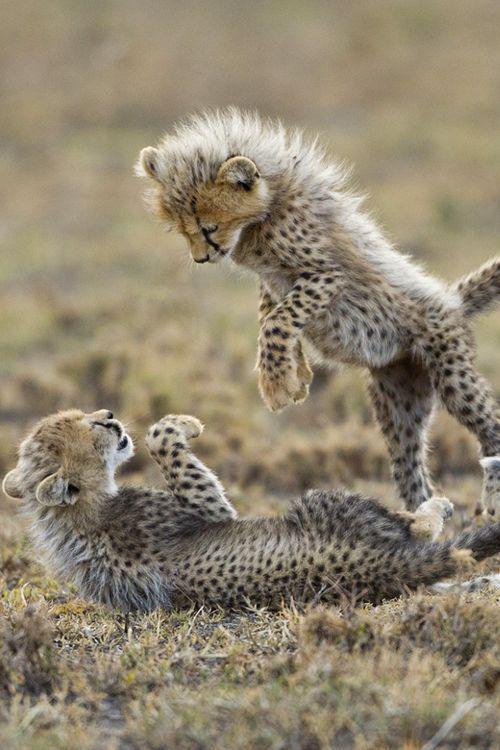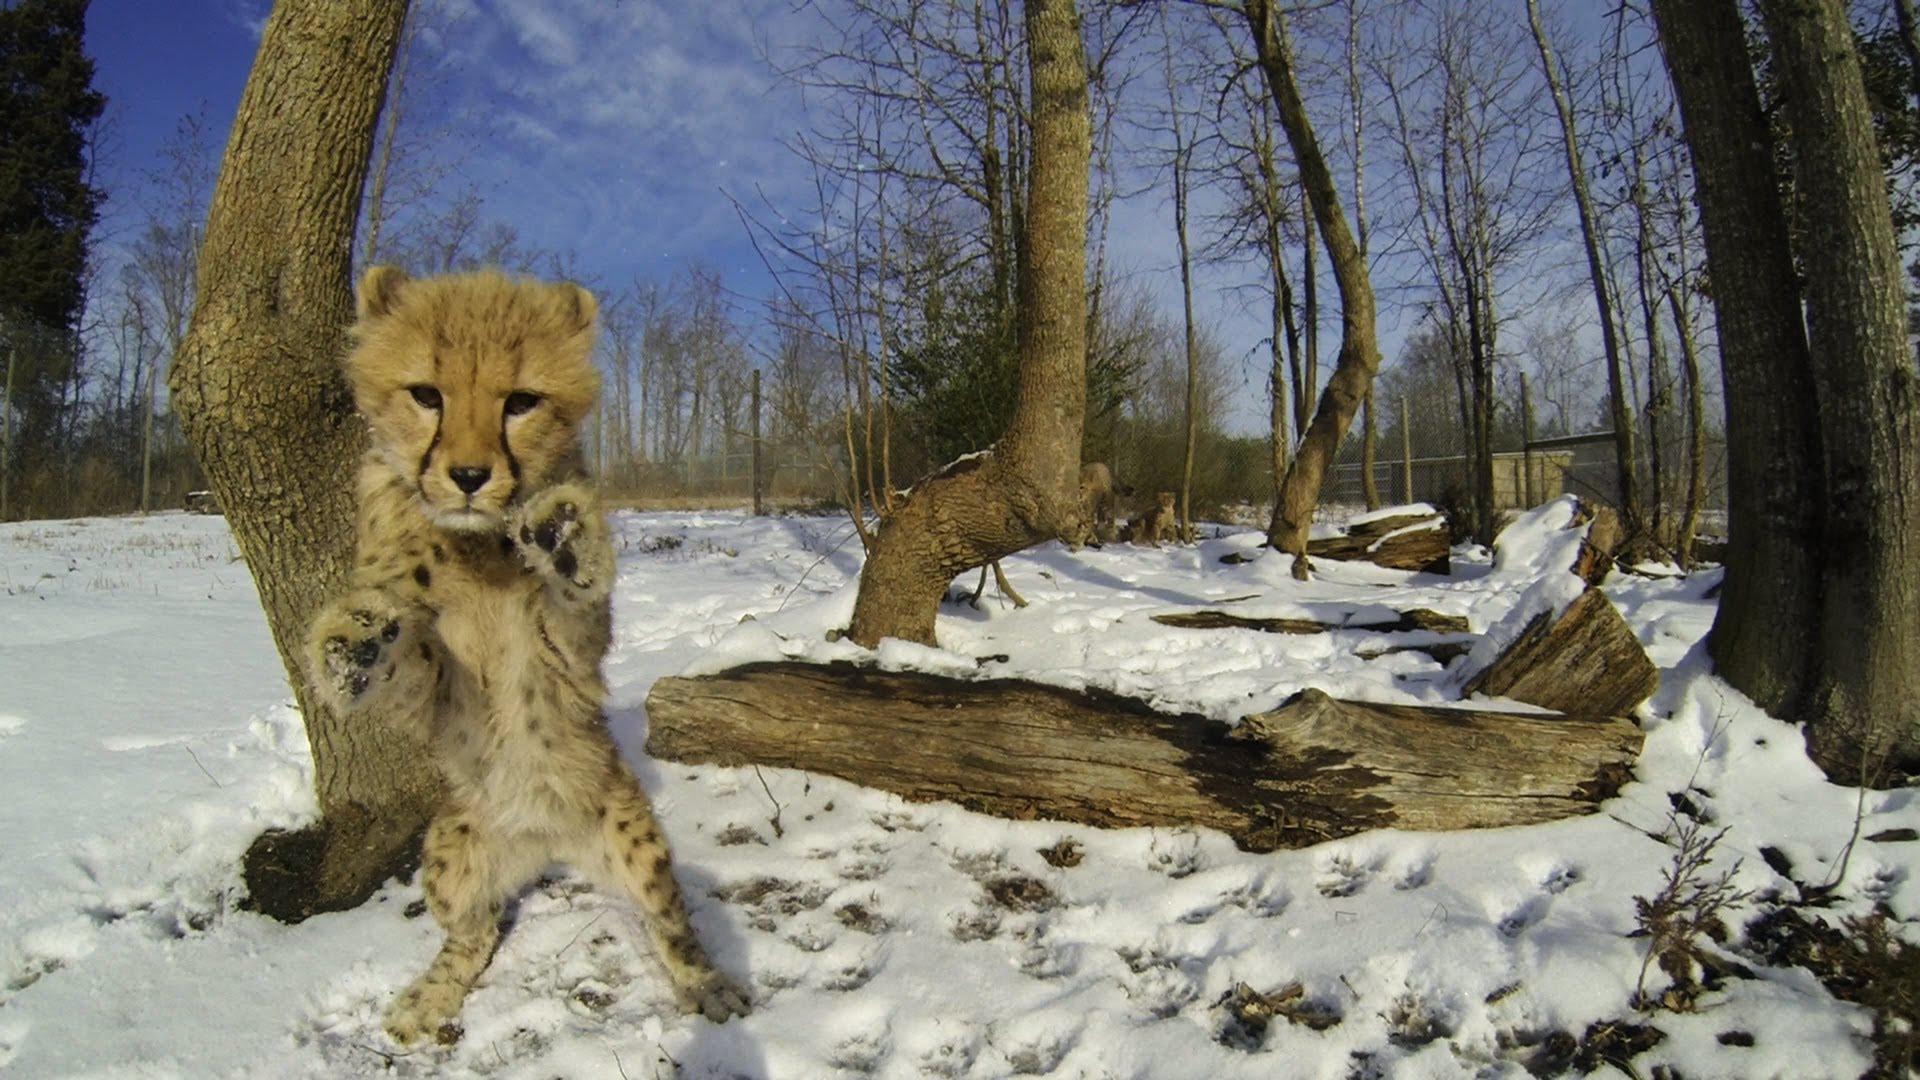The first image is the image on the left, the second image is the image on the right. For the images shown, is this caption "A spotted wild kitten with its tail extending upward is about to pounce on another kitten in one image." true? Answer yes or no. Yes. The first image is the image on the left, the second image is the image on the right. Given the left and right images, does the statement "One image has a wild cat in the middle of pouncing onto another wild cat." hold true? Answer yes or no. Yes. The first image is the image on the left, the second image is the image on the right. Considering the images on both sides, is "One of the images features a young cat leaping into the air to pounce on another cat." valid? Answer yes or no. Yes. The first image is the image on the left, the second image is the image on the right. Analyze the images presented: Is the assertion "There are at most 4 cheetahs." valid? Answer yes or no. Yes. 